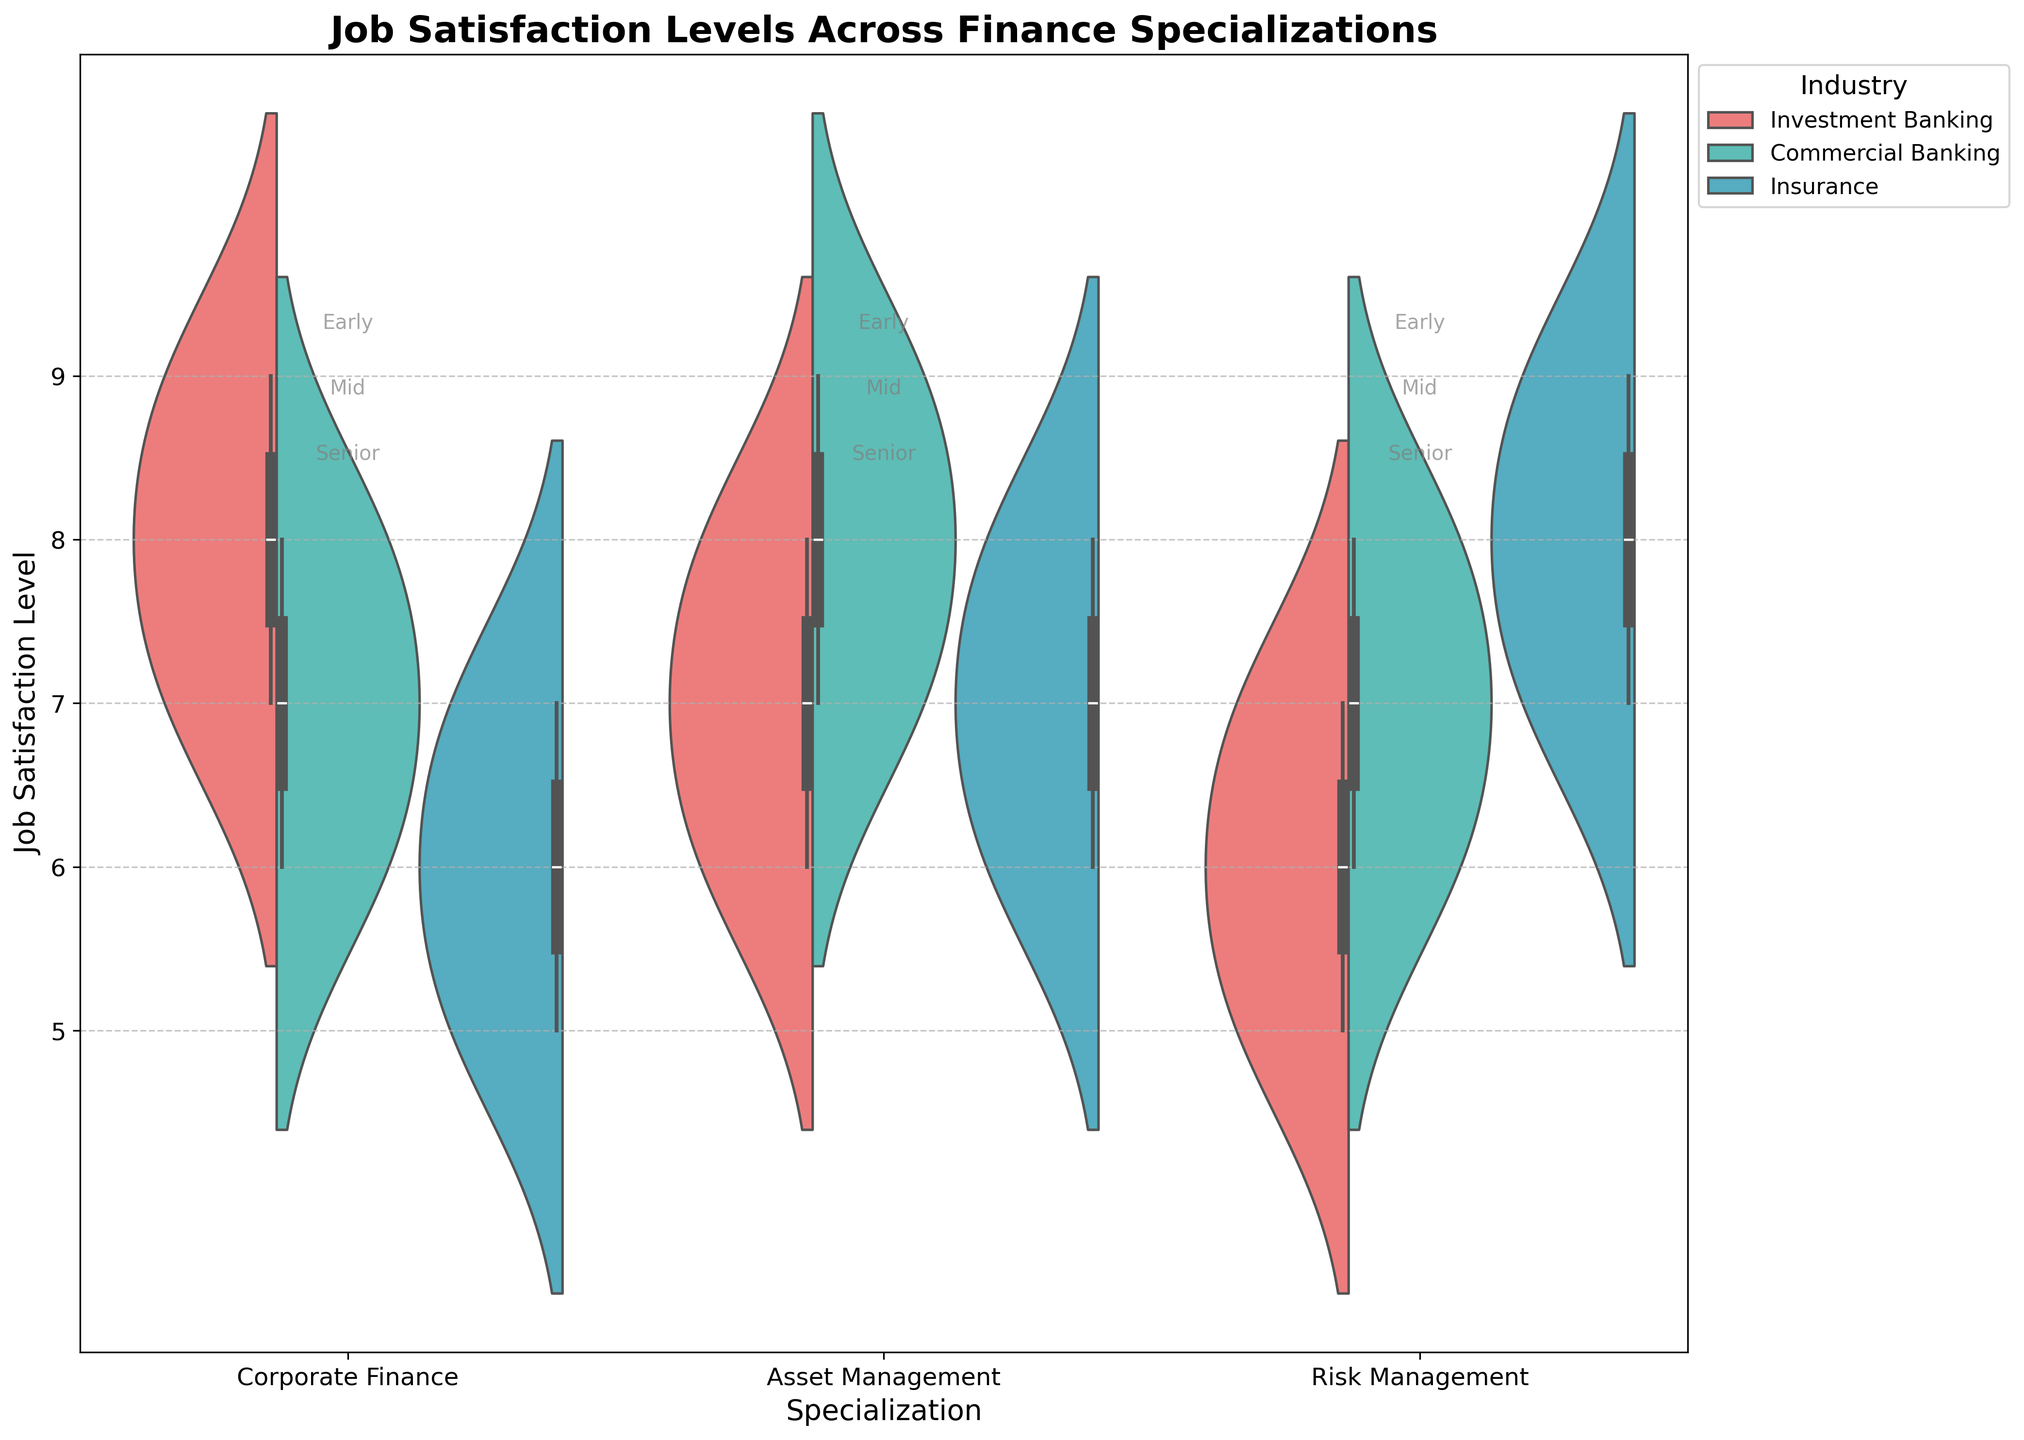What are the specializations considered in this chart? The x-axis labels of the chart show the different specializations being considered. Looking at the x-axis, the specializations are Corporate Finance, Asset Management, and Risk Management.
Answer: Corporate Finance, Asset Management, Risk Management Which industry has the highest job satisfaction level for Senior career stages in the specialization of Risk Management? In the chart, the Job Satisfaction Level for Senior career stages can be seen for each industry within the specialization of Risk Management. The highest levels are represented by the highest points on the violin plot and are found to be in Insurance, with a value of 9.
Answer: Insurance What's the difference in job satisfaction levels between Mid and Senior career stages for the specialization of Corporate Finance in the Investment Banking industry? The chart shows the distributions of job satisfaction levels by career stage within each specialization and industry combination. For Corporate Finance in Investment Banking, the Mid career stage has a job satisfaction level of 8, and the Senior career stage has a job satisfaction level of 9. The difference is calculated as 9 - 8.
Answer: 1 How does the job satisfaction level in the early career stage for Asset Management in Commercial Banking compare to that in Insurance? Compare the height of the violin plots for the Early career stage within the Asset Management specialization in both Commercial Banking and Insurance. The chart shows a level of 7 for Commercial Banking and 6 for Insurance. So, Commercial Banking has a higher job satisfaction level by 1 point.
Answer: Higher by 1 What is a common trend observed across career stages in the Corporate Finance specialization? The chart shows the distributions across different career stages within Corporate Finance specialization. A common trend can be observed where job satisfaction levels generally increase from Early to Senior career stages across all industries.
Answer: Increase with career stages Which specialization in the Insurance industry shows a consistent increase in job satisfaction levels across all career stages? By looking at the Job Satisfaction Levels exhibited in the violin plots for each specialization within the Insurance industry, Risk Management shows a consistent increase: Early (7), Mid (8), and Senior (9).
Answer: Risk Management Is there any outlier in job satisfaction levels for Mid career stage in Risk Management specialization within Commercial Banking? To determine if there is an outlier, we look at the box within the violin plot for Risk Management in Commercial Banking at Mid career stage. The box represents the interquartile range. In this case, there are no outliers indicated.
Answer: No outlier Which industry-solid specialization combination has the most variation in job satisfaction levels for the Early career stage? Variation can be observed by the width of the violin plots. For the Early career stage, the widest violin plot, indicating the most variation, is seen in Corporate Finance within Commercial Banking.
Answer: Corporate Finance in Commercial Banking 